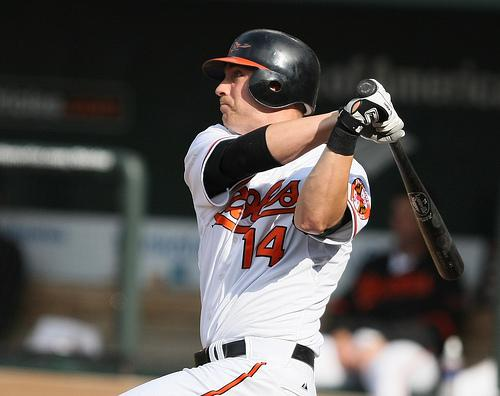Question: what color is the man's helmet?
Choices:
A. Black.
B. Blue.
C. White.
D. Orange and black.
Answer with the letter. Answer: D Question: what is the man doing?
Choices:
A. Swinging a Tennis Racket.
B. Kicking a soccer ball.
C. Swinging a bat.
D. Throwing a football.
Answer with the letter. Answer: C Question: what color is the bat?
Choices:
A. Black.
B. Brown.
C. White.
D. Silver.
Answer with the letter. Answer: A Question: who is holding the bat?
Choices:
A. The boy.
B. Baseball player.
C. Young man.
D. The man.
Answer with the letter. Answer: D 